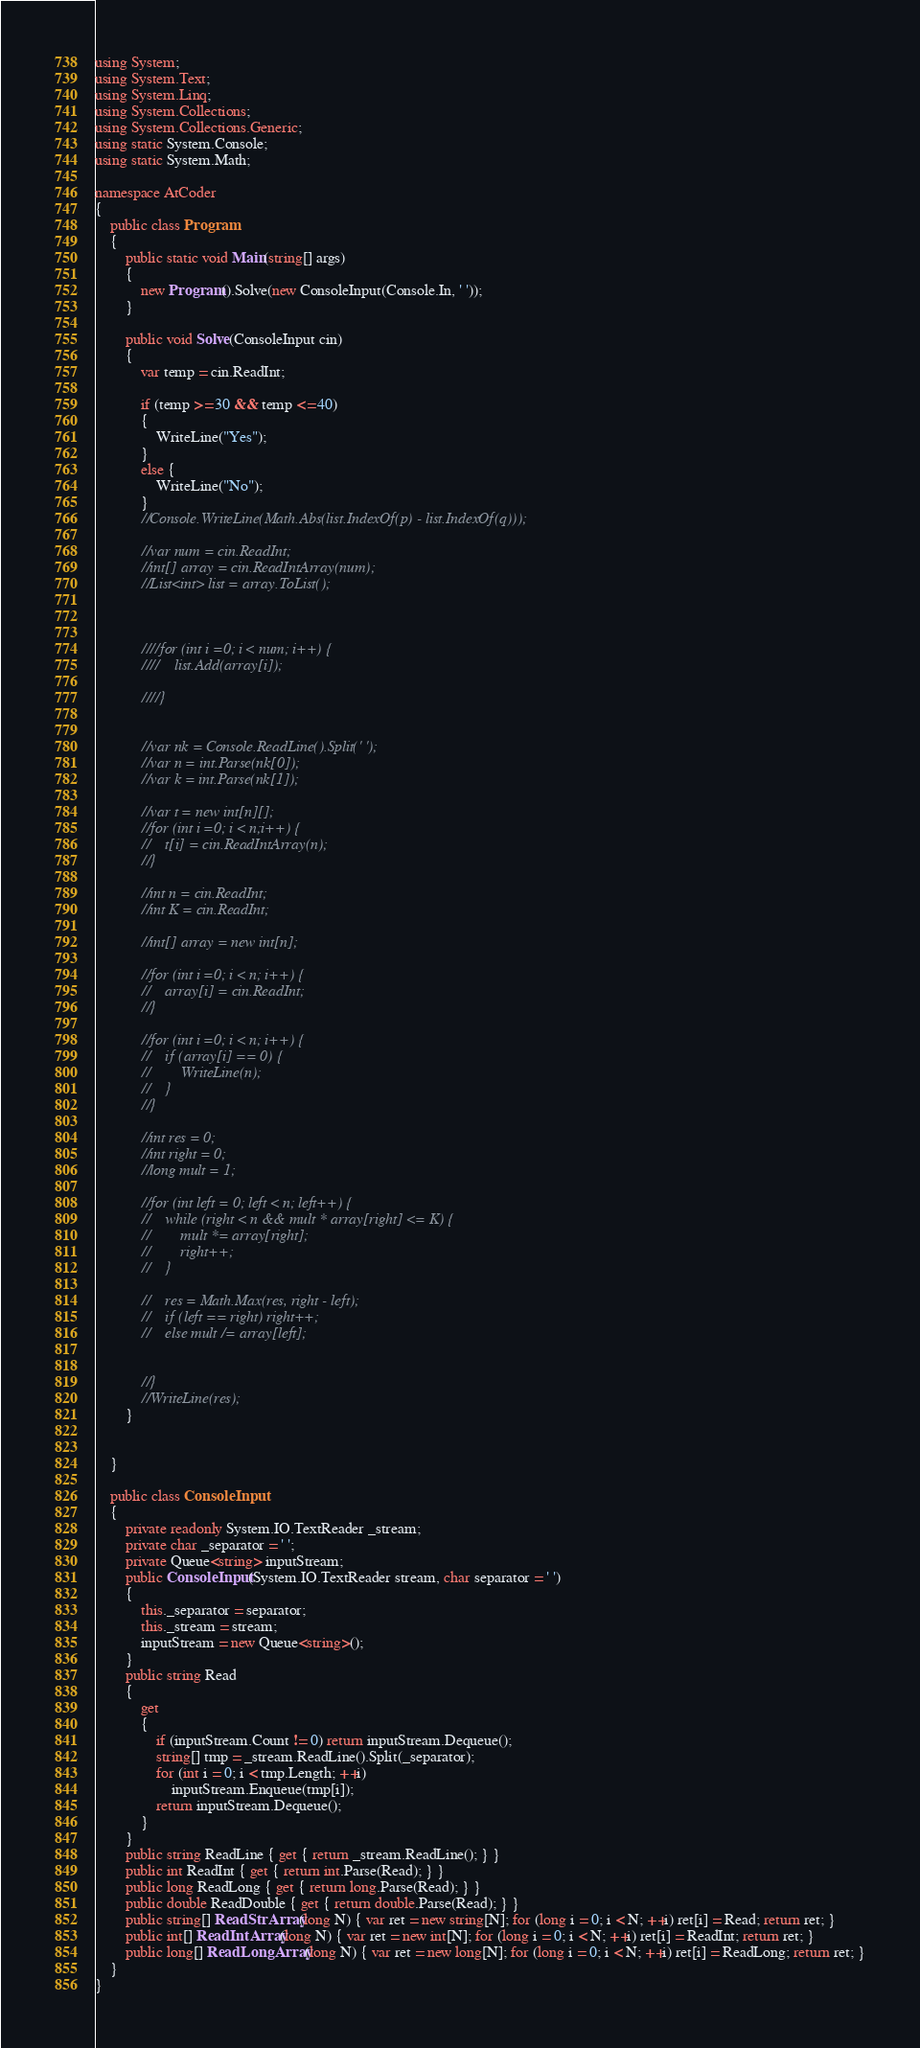Convert code to text. <code><loc_0><loc_0><loc_500><loc_500><_C#_>using System;
using System.Text;
using System.Linq;
using System.Collections;
using System.Collections.Generic;
using static System.Console;
using static System.Math;

namespace AtCoder
{
    public class Program
    {
        public static void Main(string[] args)
        {
            new Program().Solve(new ConsoleInput(Console.In, ' '));
        }

        public void Solve(ConsoleInput cin)
        {
            var temp = cin.ReadInt;

            if (temp >= 30 && temp <= 40)
            {
                WriteLine("Yes");
            }
            else {
                WriteLine("No");
            }
            //Console.WriteLine(Math.Abs(list.IndexOf(p) - list.IndexOf(q)));

            //var num = cin.ReadInt;
            //int[] array = cin.ReadIntArray(num);
            //List<int> list = array.ToList();



            ////for (int i =0; i < num; i++) {
            ////    list.Add(array[i]);

            ////}


            //var nk = Console.ReadLine().Split(' ');
            //var n = int.Parse(nk[0]);
            //var k = int.Parse(nk[1]);

            //var t = new int[n][];
            //for (int i =0; i < n;i++) {
            //    t[i] = cin.ReadIntArray(n);
            //}

            //int n = cin.ReadInt;
            //int K = cin.ReadInt;

            //int[] array = new int[n];

            //for (int i =0; i < n; i++) {
            //    array[i] = cin.ReadInt;
            //}

            //for (int i =0; i < n; i++) {
            //    if (array[i] == 0) {
            //        WriteLine(n);
            //    }
            //}

            //int res = 0;
            //int right = 0;
            //long mult = 1;

            //for (int left = 0; left < n; left++) {
            //    while (right < n && mult * array[right] <= K) {
            //        mult *= array[right];
            //        right++;
            //    }

            //    res = Math.Max(res, right - left);
            //    if (left == right) right++;
            //    else mult /= array[left];


            //}
            //WriteLine(res);
        }


    }

    public class ConsoleInput
    {
        private readonly System.IO.TextReader _stream;
        private char _separator = ' ';
        private Queue<string> inputStream;
        public ConsoleInput(System.IO.TextReader stream, char separator = ' ')
        {
            this._separator = separator;
            this._stream = stream;
            inputStream = new Queue<string>();
        }
        public string Read
        {
            get
            {
                if (inputStream.Count != 0) return inputStream.Dequeue();
                string[] tmp = _stream.ReadLine().Split(_separator);
                for (int i = 0; i < tmp.Length; ++i)
                    inputStream.Enqueue(tmp[i]);
                return inputStream.Dequeue();
            }
        }
        public string ReadLine { get { return _stream.ReadLine(); } }
        public int ReadInt { get { return int.Parse(Read); } }
        public long ReadLong { get { return long.Parse(Read); } }
        public double ReadDouble { get { return double.Parse(Read); } }
        public string[] ReadStrArray(long N) { var ret = new string[N]; for (long i = 0; i < N; ++i) ret[i] = Read; return ret; }
        public int[] ReadIntArray(long N) { var ret = new int[N]; for (long i = 0; i < N; ++i) ret[i] = ReadInt; return ret; }
        public long[] ReadLongArray(long N) { var ret = new long[N]; for (long i = 0; i < N; ++i) ret[i] = ReadLong; return ret; }
    }
}</code> 